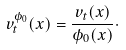<formula> <loc_0><loc_0><loc_500><loc_500>v ^ { \phi _ { 0 } } _ { t } ( x ) = \frac { v _ { t } ( x ) } { \phi _ { 0 } ( x ) } \cdot</formula> 